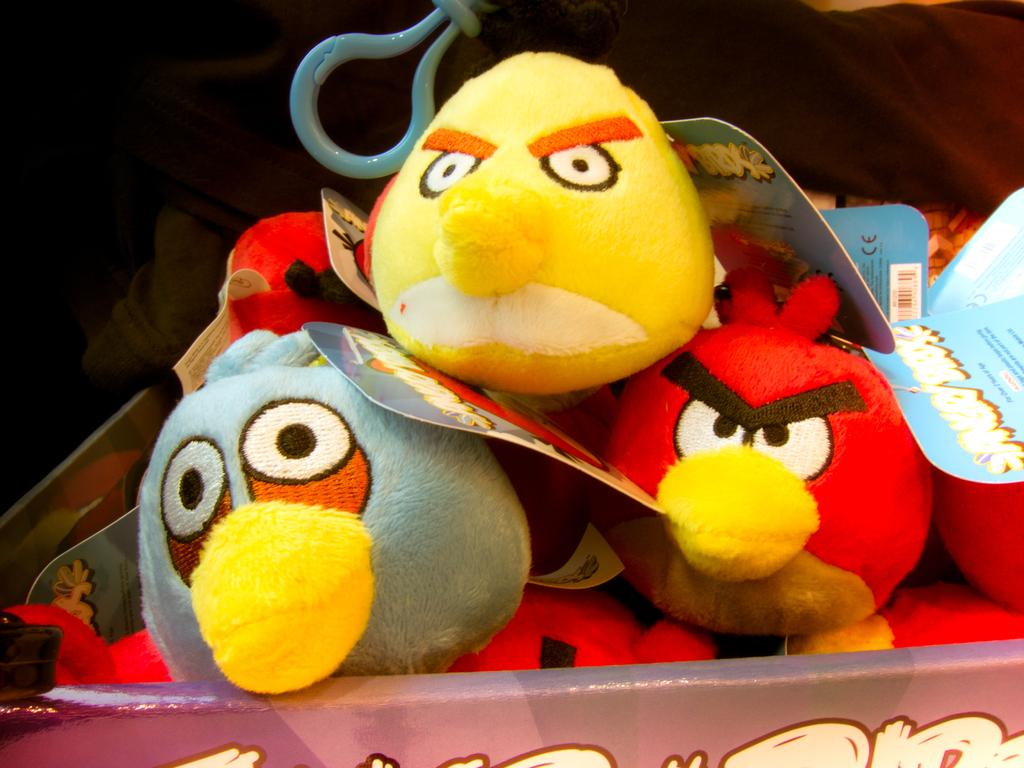What objects can be seen in the image? There are toys in the image. Is there any additional information provided on the toys? Yes, there is a tag in the image. What can be said about the overall appearance of the image? The background of the image is dark. What type of teeth can be seen in the image? There are no teeth present in the image; it features toys and a tag. 